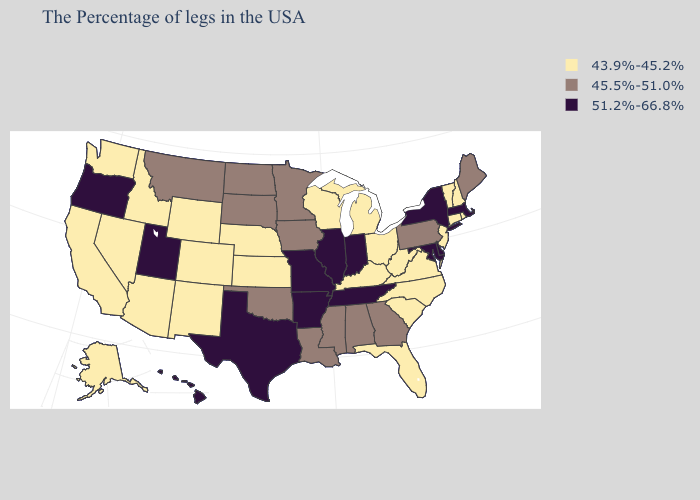What is the highest value in states that border Wyoming?
Be succinct. 51.2%-66.8%. What is the value of Kentucky?
Give a very brief answer. 43.9%-45.2%. Does Michigan have a higher value than Pennsylvania?
Quick response, please. No. What is the value of Arizona?
Answer briefly. 43.9%-45.2%. What is the highest value in states that border Pennsylvania?
Be succinct. 51.2%-66.8%. Does Minnesota have a lower value than Idaho?
Be succinct. No. What is the value of New Mexico?
Give a very brief answer. 43.9%-45.2%. Name the states that have a value in the range 43.9%-45.2%?
Give a very brief answer. Rhode Island, New Hampshire, Vermont, Connecticut, New Jersey, Virginia, North Carolina, South Carolina, West Virginia, Ohio, Florida, Michigan, Kentucky, Wisconsin, Kansas, Nebraska, Wyoming, Colorado, New Mexico, Arizona, Idaho, Nevada, California, Washington, Alaska. Name the states that have a value in the range 51.2%-66.8%?
Concise answer only. Massachusetts, New York, Delaware, Maryland, Indiana, Tennessee, Illinois, Missouri, Arkansas, Texas, Utah, Oregon, Hawaii. Does New Mexico have a higher value than Nebraska?
Answer briefly. No. Does Oklahoma have a higher value than Oregon?
Quick response, please. No. Name the states that have a value in the range 45.5%-51.0%?
Give a very brief answer. Maine, Pennsylvania, Georgia, Alabama, Mississippi, Louisiana, Minnesota, Iowa, Oklahoma, South Dakota, North Dakota, Montana. Name the states that have a value in the range 51.2%-66.8%?
Answer briefly. Massachusetts, New York, Delaware, Maryland, Indiana, Tennessee, Illinois, Missouri, Arkansas, Texas, Utah, Oregon, Hawaii. 